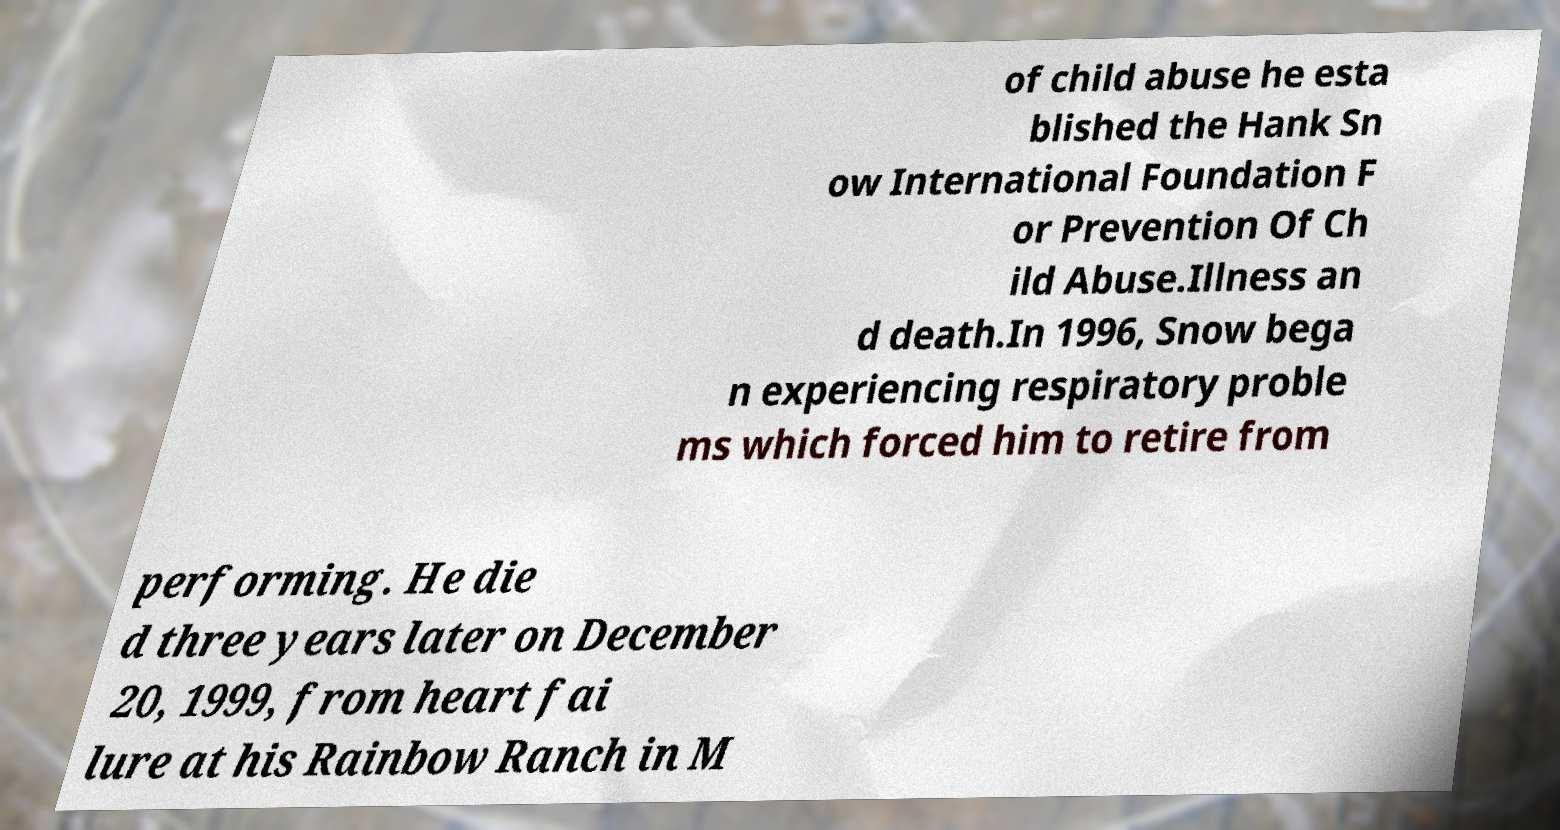Can you accurately transcribe the text from the provided image for me? of child abuse he esta blished the Hank Sn ow International Foundation F or Prevention Of Ch ild Abuse.Illness an d death.In 1996, Snow bega n experiencing respiratory proble ms which forced him to retire from performing. He die d three years later on December 20, 1999, from heart fai lure at his Rainbow Ranch in M 